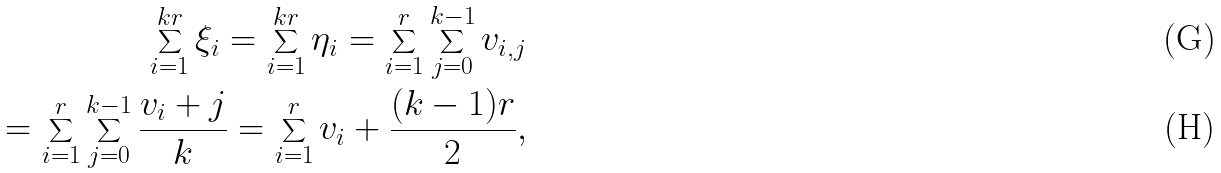Convert formula to latex. <formula><loc_0><loc_0><loc_500><loc_500>\sum _ { i = 1 } ^ { k r } \xi _ { i } = \sum _ { i = 1 } ^ { k r } \eta _ { i } = \sum _ { i = 1 } ^ { r } \sum _ { j = 0 } ^ { k - 1 } v _ { i , j } \\ = \sum _ { i = 1 } ^ { r } \sum _ { j = 0 } ^ { k - 1 } \frac { v _ { i } + j } { k } = \sum _ { i = 1 } ^ { r } v _ { i } + \frac { ( k - 1 ) r } { 2 } ,</formula> 